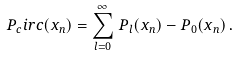Convert formula to latex. <formula><loc_0><loc_0><loc_500><loc_500>P _ { c } i r c ( x _ { n } ) = \sum _ { l = 0 } ^ { \infty } \, P _ { l } ( x _ { n } ) - P _ { 0 } ( x _ { n } ) \, .</formula> 